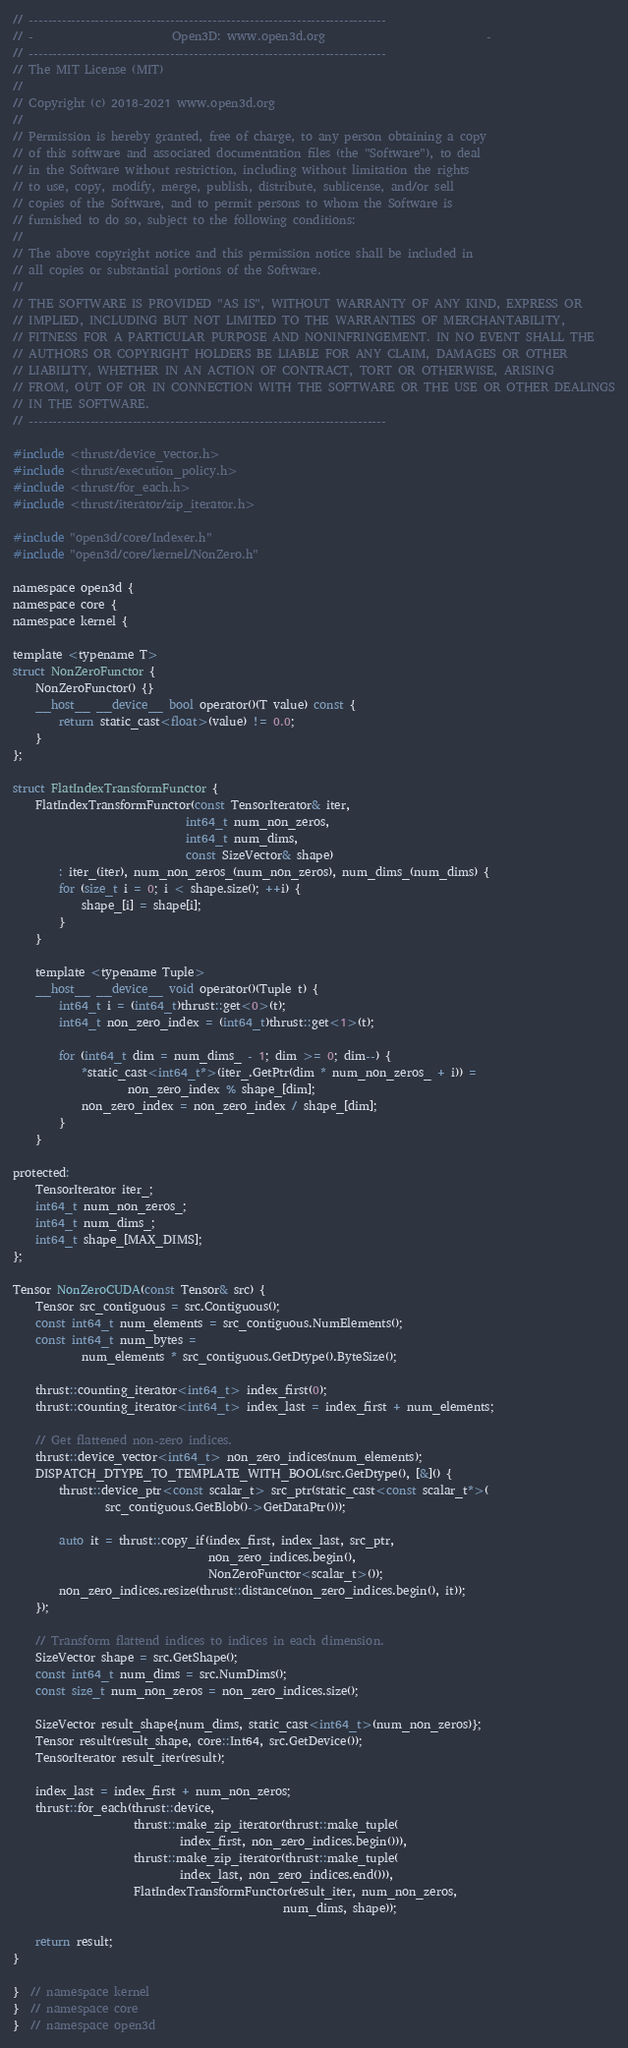<code> <loc_0><loc_0><loc_500><loc_500><_Cuda_>// ----------------------------------------------------------------------------
// -                        Open3D: www.open3d.org                            -
// ----------------------------------------------------------------------------
// The MIT License (MIT)
//
// Copyright (c) 2018-2021 www.open3d.org
//
// Permission is hereby granted, free of charge, to any person obtaining a copy
// of this software and associated documentation files (the "Software"), to deal
// in the Software without restriction, including without limitation the rights
// to use, copy, modify, merge, publish, distribute, sublicense, and/or sell
// copies of the Software, and to permit persons to whom the Software is
// furnished to do so, subject to the following conditions:
//
// The above copyright notice and this permission notice shall be included in
// all copies or substantial portions of the Software.
//
// THE SOFTWARE IS PROVIDED "AS IS", WITHOUT WARRANTY OF ANY KIND, EXPRESS OR
// IMPLIED, INCLUDING BUT NOT LIMITED TO THE WARRANTIES OF MERCHANTABILITY,
// FITNESS FOR A PARTICULAR PURPOSE AND NONINFRINGEMENT. IN NO EVENT SHALL THE
// AUTHORS OR COPYRIGHT HOLDERS BE LIABLE FOR ANY CLAIM, DAMAGES OR OTHER
// LIABILITY, WHETHER IN AN ACTION OF CONTRACT, TORT OR OTHERWISE, ARISING
// FROM, OUT OF OR IN CONNECTION WITH THE SOFTWARE OR THE USE OR OTHER DEALINGS
// IN THE SOFTWARE.
// ----------------------------------------------------------------------------

#include <thrust/device_vector.h>
#include <thrust/execution_policy.h>
#include <thrust/for_each.h>
#include <thrust/iterator/zip_iterator.h>

#include "open3d/core/Indexer.h"
#include "open3d/core/kernel/NonZero.h"

namespace open3d {
namespace core {
namespace kernel {

template <typename T>
struct NonZeroFunctor {
    NonZeroFunctor() {}
    __host__ __device__ bool operator()(T value) const {
        return static_cast<float>(value) != 0.0;
    }
};

struct FlatIndexTransformFunctor {
    FlatIndexTransformFunctor(const TensorIterator& iter,
                              int64_t num_non_zeros,
                              int64_t num_dims,
                              const SizeVector& shape)
        : iter_(iter), num_non_zeros_(num_non_zeros), num_dims_(num_dims) {
        for (size_t i = 0; i < shape.size(); ++i) {
            shape_[i] = shape[i];
        }
    }

    template <typename Tuple>
    __host__ __device__ void operator()(Tuple t) {
        int64_t i = (int64_t)thrust::get<0>(t);
        int64_t non_zero_index = (int64_t)thrust::get<1>(t);

        for (int64_t dim = num_dims_ - 1; dim >= 0; dim--) {
            *static_cast<int64_t*>(iter_.GetPtr(dim * num_non_zeros_ + i)) =
                    non_zero_index % shape_[dim];
            non_zero_index = non_zero_index / shape_[dim];
        }
    }

protected:
    TensorIterator iter_;
    int64_t num_non_zeros_;
    int64_t num_dims_;
    int64_t shape_[MAX_DIMS];
};

Tensor NonZeroCUDA(const Tensor& src) {
    Tensor src_contiguous = src.Contiguous();
    const int64_t num_elements = src_contiguous.NumElements();
    const int64_t num_bytes =
            num_elements * src_contiguous.GetDtype().ByteSize();

    thrust::counting_iterator<int64_t> index_first(0);
    thrust::counting_iterator<int64_t> index_last = index_first + num_elements;

    // Get flattened non-zero indices.
    thrust::device_vector<int64_t> non_zero_indices(num_elements);
    DISPATCH_DTYPE_TO_TEMPLATE_WITH_BOOL(src.GetDtype(), [&]() {
        thrust::device_ptr<const scalar_t> src_ptr(static_cast<const scalar_t*>(
                src_contiguous.GetBlob()->GetDataPtr()));

        auto it = thrust::copy_if(index_first, index_last, src_ptr,
                                  non_zero_indices.begin(),
                                  NonZeroFunctor<scalar_t>());
        non_zero_indices.resize(thrust::distance(non_zero_indices.begin(), it));
    });

    // Transform flattend indices to indices in each dimension.
    SizeVector shape = src.GetShape();
    const int64_t num_dims = src.NumDims();
    const size_t num_non_zeros = non_zero_indices.size();

    SizeVector result_shape{num_dims, static_cast<int64_t>(num_non_zeros)};
    Tensor result(result_shape, core::Int64, src.GetDevice());
    TensorIterator result_iter(result);

    index_last = index_first + num_non_zeros;
    thrust::for_each(thrust::device,
                     thrust::make_zip_iterator(thrust::make_tuple(
                             index_first, non_zero_indices.begin())),
                     thrust::make_zip_iterator(thrust::make_tuple(
                             index_last, non_zero_indices.end())),
                     FlatIndexTransformFunctor(result_iter, num_non_zeros,
                                               num_dims, shape));

    return result;
}

}  // namespace kernel
}  // namespace core
}  // namespace open3d
</code> 